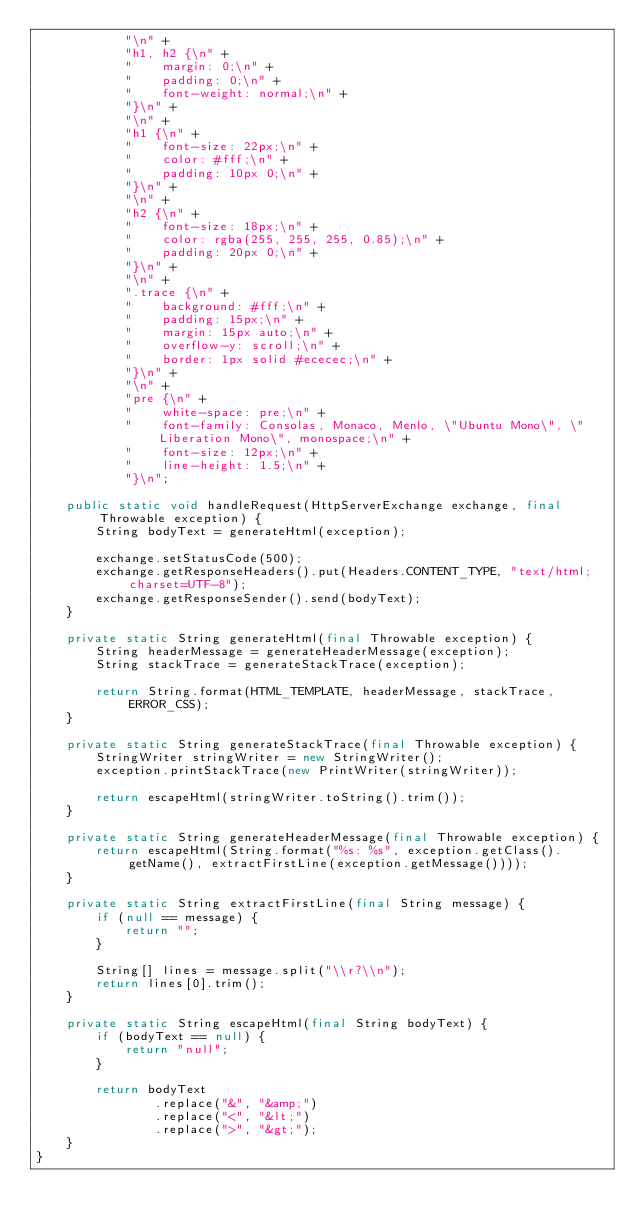Convert code to text. <code><loc_0><loc_0><loc_500><loc_500><_Java_>            "\n" +
            "h1, h2 {\n" +
            "    margin: 0;\n" +
            "    padding: 0;\n" +
            "    font-weight: normal;\n" +
            "}\n" +
            "\n" +
            "h1 {\n" +
            "    font-size: 22px;\n" +
            "    color: #fff;\n" +
            "    padding: 10px 0;\n" +
            "}\n" +
            "\n" +
            "h2 {\n" +
            "    font-size: 18px;\n" +
            "    color: rgba(255, 255, 255, 0.85);\n" +
            "    padding: 20px 0;\n" +
            "}\n" +
            "\n" +
            ".trace {\n" +
            "    background: #fff;\n" +
            "    padding: 15px;\n" +
            "    margin: 15px auto;\n" +
            "    overflow-y: scroll;\n" +
            "    border: 1px solid #ececec;\n" +
            "}\n" +
            "\n" +
            "pre {\n" +
            "    white-space: pre;\n" +
            "    font-family: Consolas, Monaco, Menlo, \"Ubuntu Mono\", \"Liberation Mono\", monospace;\n" +
            "    font-size: 12px;\n" +
            "    line-height: 1.5;\n" +
            "}\n";

    public static void handleRequest(HttpServerExchange exchange, final Throwable exception) {
        String bodyText = generateHtml(exception);

        exchange.setStatusCode(500);
        exchange.getResponseHeaders().put(Headers.CONTENT_TYPE, "text/html; charset=UTF-8");
        exchange.getResponseSender().send(bodyText);
    }

    private static String generateHtml(final Throwable exception) {
        String headerMessage = generateHeaderMessage(exception);
        String stackTrace = generateStackTrace(exception);

        return String.format(HTML_TEMPLATE, headerMessage, stackTrace, ERROR_CSS);
    }

    private static String generateStackTrace(final Throwable exception) {
        StringWriter stringWriter = new StringWriter();
        exception.printStackTrace(new PrintWriter(stringWriter));

        return escapeHtml(stringWriter.toString().trim());
    }

    private static String generateHeaderMessage(final Throwable exception) {
        return escapeHtml(String.format("%s: %s", exception.getClass().getName(), extractFirstLine(exception.getMessage())));
    }

    private static String extractFirstLine(final String message) {
        if (null == message) {
            return "";
        }

        String[] lines = message.split("\\r?\\n");
        return lines[0].trim();
    }

    private static String escapeHtml(final String bodyText) {
        if (bodyText == null) {
            return "null";
        }

        return bodyText
                .replace("&", "&amp;")
                .replace("<", "&lt;")
                .replace(">", "&gt;");
    }
}
</code> 